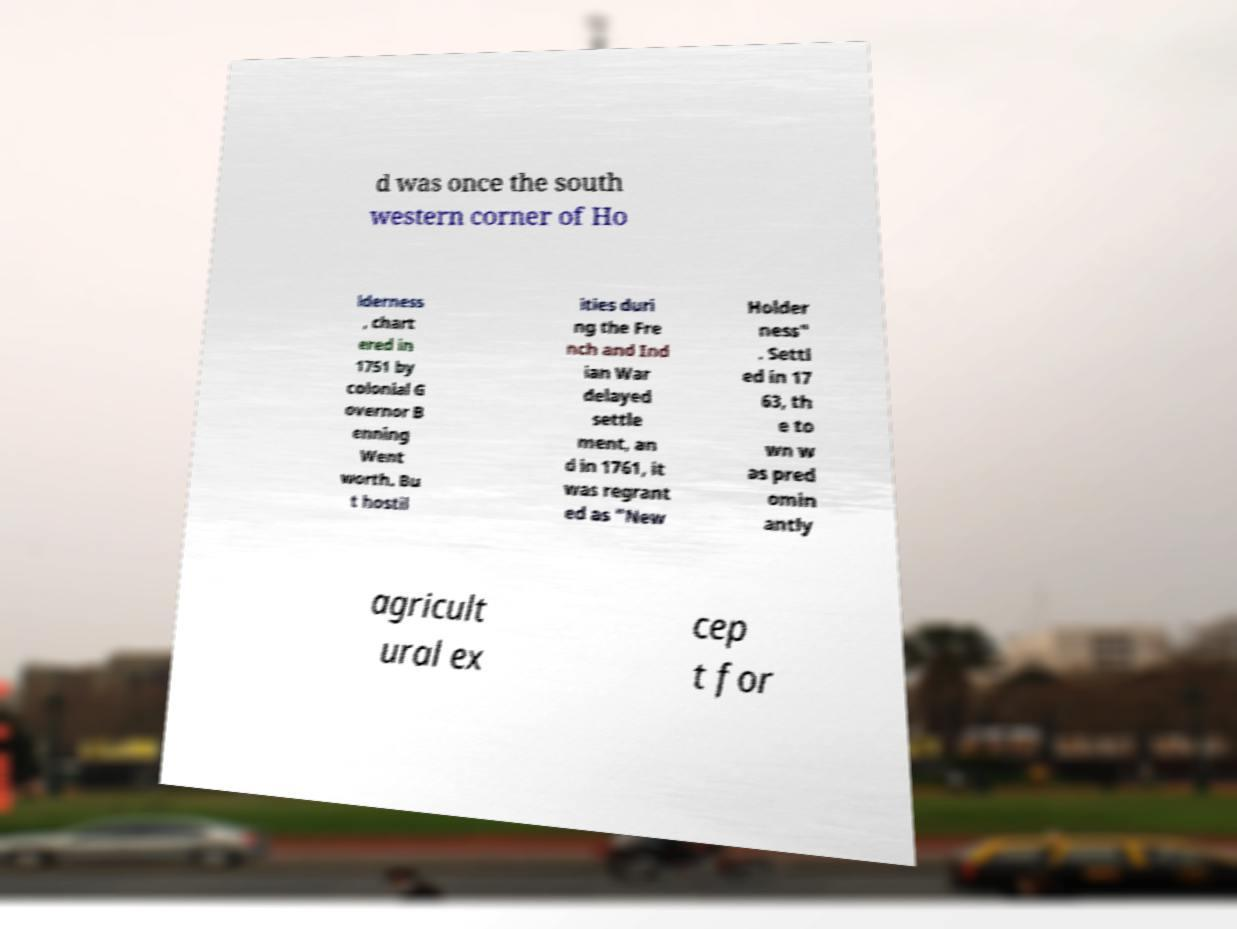There's text embedded in this image that I need extracted. Can you transcribe it verbatim? d was once the south western corner of Ho lderness , chart ered in 1751 by colonial G overnor B enning Went worth. Bu t hostil ities duri ng the Fre nch and Ind ian War delayed settle ment, an d in 1761, it was regrant ed as "New Holder ness" . Settl ed in 17 63, th e to wn w as pred omin antly agricult ural ex cep t for 